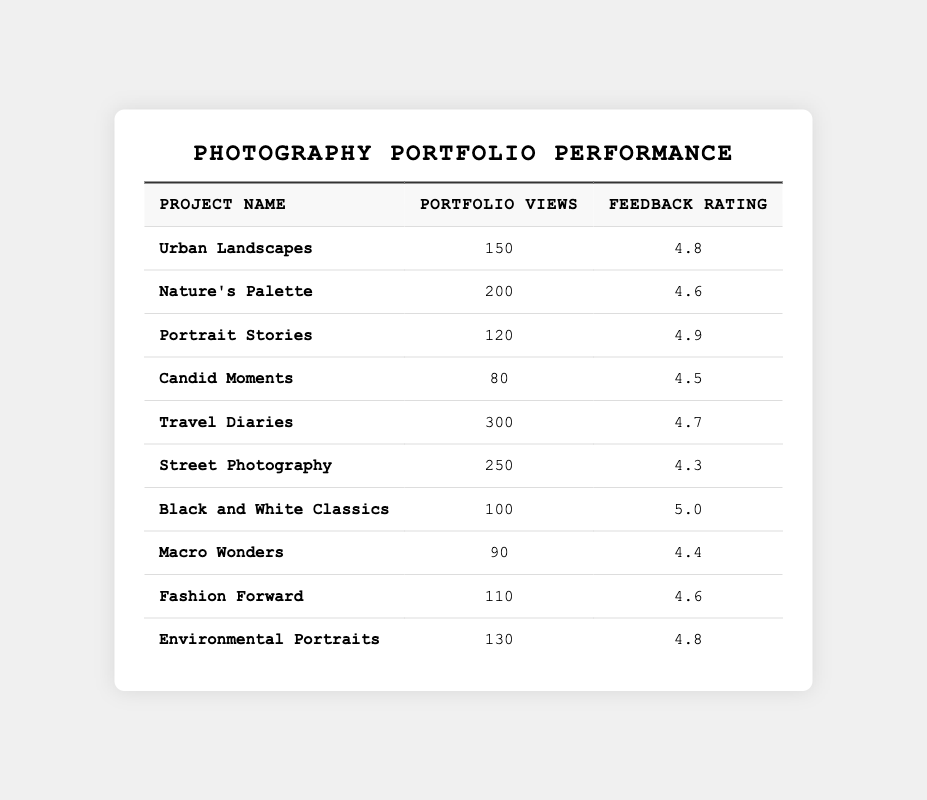What is the project with the highest feedback rating? The table shows that "Black and White Classics" has the highest feedback rating of 5.0.
Answer: Black and White Classics How many portfolio views does the project "Travel Diaries" have? The table clearly states that "Travel Diaries" has a total of 300 portfolio views.
Answer: 300 Which project received the lowest feedback rating? By examining the ratings, "Street Photography" has the lowest feedback rating of 4.3.
Answer: Street Photography What is the total number of portfolio views across all projects? Adding up all portfolio views: 150 + 200 + 120 + 80 + 300 + 250 + 100 + 90 + 110 + 130 = 1,630.
Answer: 1630 What is the average feedback rating of the projects listed? To find the average, sum all feedback ratings: (4.8 + 4.6 + 4.9 + 4.5 + 4.7 + 4.3 + 5.0 + 4.4 + 4.6 + 4.8) = 48.6, then divide by 10 (the number of projects) to get 48.6/10 = 4.86.
Answer: 4.86 How many projects have more than 200 portfolio views? The projects with over 200 views are "Nature's Palette," "Travel Diaries," and "Street Photography," totaling 3 projects.
Answer: 3 Is it true that the "Urban Landscapes" project has more views than the "Street Photography" project? Comparing the views: "Urban Landscapes" has 150 views and "Street Photography" has 250 views, so the statement is false.
Answer: False What is the difference in portfolio views between "Travel Diaries" and "Black and White Classics"? The views for "Travel Diaries" are 300, while "Black and White Classics" has 100. The difference is 300 - 100 = 200.
Answer: 200 Which project has a higher feedback rating: "Candid Moments" or "Fashion Forward"? "Candid Moments" has a rating of 4.5, while "Fashion Forward" has 4.6; therefore, "Fashion Forward" has a higher rating.
Answer: Fashion Forward How many projects have a feedback rating of 4.8 or higher? The projects with ratings of 4.8 or higher are: "Urban Landscapes" (4.8), "Portrait Stories" (4.9), "Black and White Classics" (5.0), and "Environmental Portraits" (4.8), totaling 4 projects.
Answer: 4 What is the median number of portfolio views? First, list the portfolio views in ascending order: 80, 90, 100, 110, 120, 130, 150, 200, 250, 300. Since there are 10 values, the median is the average of the 5th and 6th numbers: (120 + 130)/2 = 125.
Answer: 125 